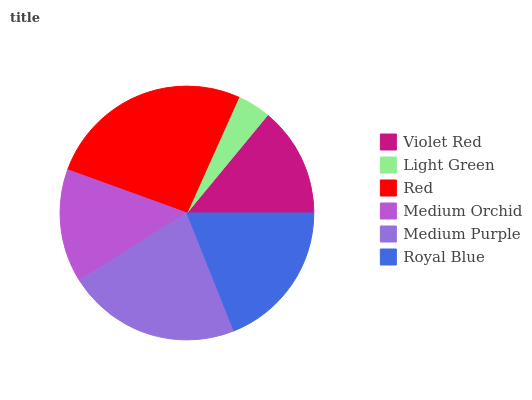Is Light Green the minimum?
Answer yes or no. Yes. Is Red the maximum?
Answer yes or no. Yes. Is Red the minimum?
Answer yes or no. No. Is Light Green the maximum?
Answer yes or no. No. Is Red greater than Light Green?
Answer yes or no. Yes. Is Light Green less than Red?
Answer yes or no. Yes. Is Light Green greater than Red?
Answer yes or no. No. Is Red less than Light Green?
Answer yes or no. No. Is Royal Blue the high median?
Answer yes or no. Yes. Is Medium Orchid the low median?
Answer yes or no. Yes. Is Violet Red the high median?
Answer yes or no. No. Is Red the low median?
Answer yes or no. No. 